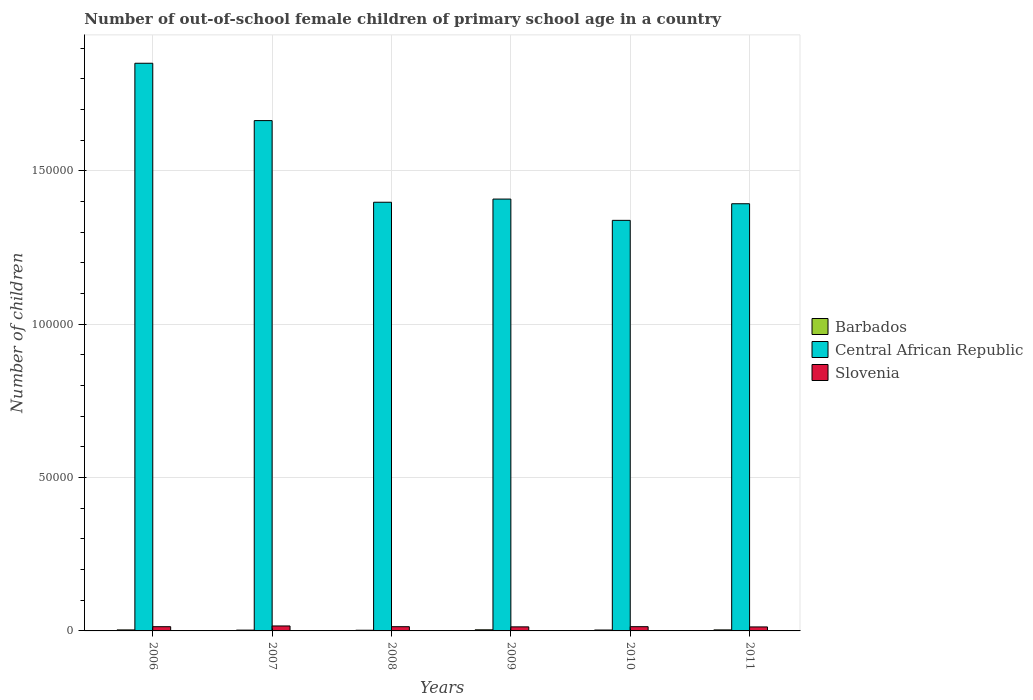How many groups of bars are there?
Give a very brief answer. 6. What is the label of the 5th group of bars from the left?
Your answer should be very brief. 2010. In how many cases, is the number of bars for a given year not equal to the number of legend labels?
Offer a terse response. 0. What is the number of out-of-school female children in Barbados in 2011?
Offer a terse response. 331. Across all years, what is the maximum number of out-of-school female children in Central African Republic?
Give a very brief answer. 1.85e+05. Across all years, what is the minimum number of out-of-school female children in Barbados?
Ensure brevity in your answer.  219. In which year was the number of out-of-school female children in Barbados minimum?
Your response must be concise. 2008. What is the total number of out-of-school female children in Central African Republic in the graph?
Offer a very short reply. 9.05e+05. What is the difference between the number of out-of-school female children in Central African Republic in 2008 and that in 2011?
Your answer should be very brief. 487. What is the difference between the number of out-of-school female children in Barbados in 2011 and the number of out-of-school female children in Central African Republic in 2009?
Your answer should be compact. -1.40e+05. What is the average number of out-of-school female children in Slovenia per year?
Your response must be concise. 1396.33. In the year 2007, what is the difference between the number of out-of-school female children in Slovenia and number of out-of-school female children in Central African Republic?
Give a very brief answer. -1.65e+05. In how many years, is the number of out-of-school female children in Slovenia greater than 160000?
Offer a very short reply. 0. What is the ratio of the number of out-of-school female children in Barbados in 2006 to that in 2011?
Ensure brevity in your answer.  0.99. Is the number of out-of-school female children in Central African Republic in 2006 less than that in 2009?
Your answer should be very brief. No. Is the difference between the number of out-of-school female children in Slovenia in 2010 and 2011 greater than the difference between the number of out-of-school female children in Central African Republic in 2010 and 2011?
Your answer should be very brief. Yes. What is the difference between the highest and the second highest number of out-of-school female children in Slovenia?
Offer a very short reply. 231. What is the difference between the highest and the lowest number of out-of-school female children in Slovenia?
Your answer should be very brief. 317. In how many years, is the number of out-of-school female children in Slovenia greater than the average number of out-of-school female children in Slovenia taken over all years?
Provide a succinct answer. 1. What does the 2nd bar from the left in 2010 represents?
Keep it short and to the point. Central African Republic. What does the 3rd bar from the right in 2009 represents?
Your response must be concise. Barbados. How many bars are there?
Ensure brevity in your answer.  18. Are all the bars in the graph horizontal?
Give a very brief answer. No. How many years are there in the graph?
Your answer should be compact. 6. What is the difference between two consecutive major ticks on the Y-axis?
Your answer should be very brief. 5.00e+04. Are the values on the major ticks of Y-axis written in scientific E-notation?
Offer a terse response. No. Does the graph contain grids?
Your response must be concise. Yes. How many legend labels are there?
Give a very brief answer. 3. What is the title of the graph?
Give a very brief answer. Number of out-of-school female children of primary school age in a country. Does "Israel" appear as one of the legend labels in the graph?
Provide a short and direct response. No. What is the label or title of the X-axis?
Your answer should be compact. Years. What is the label or title of the Y-axis?
Provide a short and direct response. Number of children. What is the Number of children in Barbados in 2006?
Keep it short and to the point. 327. What is the Number of children of Central African Republic in 2006?
Your answer should be compact. 1.85e+05. What is the Number of children in Slovenia in 2006?
Your response must be concise. 1377. What is the Number of children of Barbados in 2007?
Provide a short and direct response. 263. What is the Number of children in Central African Republic in 2007?
Your answer should be very brief. 1.66e+05. What is the Number of children in Slovenia in 2007?
Make the answer very short. 1616. What is the Number of children of Barbados in 2008?
Offer a very short reply. 219. What is the Number of children of Central African Republic in 2008?
Give a very brief answer. 1.40e+05. What is the Number of children of Slovenia in 2008?
Provide a short and direct response. 1377. What is the Number of children of Barbados in 2009?
Provide a succinct answer. 361. What is the Number of children in Central African Republic in 2009?
Your response must be concise. 1.41e+05. What is the Number of children of Slovenia in 2009?
Your answer should be compact. 1324. What is the Number of children in Barbados in 2010?
Give a very brief answer. 294. What is the Number of children in Central African Republic in 2010?
Offer a terse response. 1.34e+05. What is the Number of children in Slovenia in 2010?
Make the answer very short. 1385. What is the Number of children of Barbados in 2011?
Provide a succinct answer. 331. What is the Number of children in Central African Republic in 2011?
Give a very brief answer. 1.39e+05. What is the Number of children of Slovenia in 2011?
Keep it short and to the point. 1299. Across all years, what is the maximum Number of children of Barbados?
Make the answer very short. 361. Across all years, what is the maximum Number of children in Central African Republic?
Provide a succinct answer. 1.85e+05. Across all years, what is the maximum Number of children of Slovenia?
Your response must be concise. 1616. Across all years, what is the minimum Number of children of Barbados?
Offer a terse response. 219. Across all years, what is the minimum Number of children of Central African Republic?
Ensure brevity in your answer.  1.34e+05. Across all years, what is the minimum Number of children of Slovenia?
Offer a terse response. 1299. What is the total Number of children of Barbados in the graph?
Your response must be concise. 1795. What is the total Number of children of Central African Republic in the graph?
Offer a very short reply. 9.05e+05. What is the total Number of children in Slovenia in the graph?
Your answer should be compact. 8378. What is the difference between the Number of children of Central African Republic in 2006 and that in 2007?
Your answer should be very brief. 1.87e+04. What is the difference between the Number of children of Slovenia in 2006 and that in 2007?
Give a very brief answer. -239. What is the difference between the Number of children of Barbados in 2006 and that in 2008?
Provide a succinct answer. 108. What is the difference between the Number of children of Central African Republic in 2006 and that in 2008?
Ensure brevity in your answer.  4.53e+04. What is the difference between the Number of children in Slovenia in 2006 and that in 2008?
Ensure brevity in your answer.  0. What is the difference between the Number of children in Barbados in 2006 and that in 2009?
Give a very brief answer. -34. What is the difference between the Number of children in Central African Republic in 2006 and that in 2009?
Provide a short and direct response. 4.43e+04. What is the difference between the Number of children in Barbados in 2006 and that in 2010?
Offer a very short reply. 33. What is the difference between the Number of children in Central African Republic in 2006 and that in 2010?
Provide a short and direct response. 5.12e+04. What is the difference between the Number of children of Slovenia in 2006 and that in 2010?
Offer a terse response. -8. What is the difference between the Number of children of Barbados in 2006 and that in 2011?
Your response must be concise. -4. What is the difference between the Number of children in Central African Republic in 2006 and that in 2011?
Give a very brief answer. 4.58e+04. What is the difference between the Number of children of Slovenia in 2006 and that in 2011?
Give a very brief answer. 78. What is the difference between the Number of children of Barbados in 2007 and that in 2008?
Your answer should be very brief. 44. What is the difference between the Number of children of Central African Republic in 2007 and that in 2008?
Provide a short and direct response. 2.66e+04. What is the difference between the Number of children of Slovenia in 2007 and that in 2008?
Your response must be concise. 239. What is the difference between the Number of children in Barbados in 2007 and that in 2009?
Your answer should be compact. -98. What is the difference between the Number of children in Central African Republic in 2007 and that in 2009?
Provide a succinct answer. 2.56e+04. What is the difference between the Number of children in Slovenia in 2007 and that in 2009?
Make the answer very short. 292. What is the difference between the Number of children in Barbados in 2007 and that in 2010?
Keep it short and to the point. -31. What is the difference between the Number of children in Central African Republic in 2007 and that in 2010?
Provide a short and direct response. 3.25e+04. What is the difference between the Number of children in Slovenia in 2007 and that in 2010?
Your answer should be very brief. 231. What is the difference between the Number of children in Barbados in 2007 and that in 2011?
Your answer should be very brief. -68. What is the difference between the Number of children of Central African Republic in 2007 and that in 2011?
Provide a succinct answer. 2.71e+04. What is the difference between the Number of children in Slovenia in 2007 and that in 2011?
Provide a short and direct response. 317. What is the difference between the Number of children in Barbados in 2008 and that in 2009?
Provide a short and direct response. -142. What is the difference between the Number of children in Central African Republic in 2008 and that in 2009?
Give a very brief answer. -1034. What is the difference between the Number of children of Slovenia in 2008 and that in 2009?
Make the answer very short. 53. What is the difference between the Number of children of Barbados in 2008 and that in 2010?
Keep it short and to the point. -75. What is the difference between the Number of children of Central African Republic in 2008 and that in 2010?
Offer a terse response. 5907. What is the difference between the Number of children of Slovenia in 2008 and that in 2010?
Ensure brevity in your answer.  -8. What is the difference between the Number of children of Barbados in 2008 and that in 2011?
Offer a terse response. -112. What is the difference between the Number of children in Central African Republic in 2008 and that in 2011?
Give a very brief answer. 487. What is the difference between the Number of children of Central African Republic in 2009 and that in 2010?
Provide a succinct answer. 6941. What is the difference between the Number of children in Slovenia in 2009 and that in 2010?
Your answer should be very brief. -61. What is the difference between the Number of children in Barbados in 2009 and that in 2011?
Ensure brevity in your answer.  30. What is the difference between the Number of children of Central African Republic in 2009 and that in 2011?
Your response must be concise. 1521. What is the difference between the Number of children in Slovenia in 2009 and that in 2011?
Make the answer very short. 25. What is the difference between the Number of children of Barbados in 2010 and that in 2011?
Your answer should be very brief. -37. What is the difference between the Number of children of Central African Republic in 2010 and that in 2011?
Provide a short and direct response. -5420. What is the difference between the Number of children in Barbados in 2006 and the Number of children in Central African Republic in 2007?
Keep it short and to the point. -1.66e+05. What is the difference between the Number of children of Barbados in 2006 and the Number of children of Slovenia in 2007?
Your response must be concise. -1289. What is the difference between the Number of children in Central African Republic in 2006 and the Number of children in Slovenia in 2007?
Give a very brief answer. 1.83e+05. What is the difference between the Number of children in Barbados in 2006 and the Number of children in Central African Republic in 2008?
Your response must be concise. -1.39e+05. What is the difference between the Number of children in Barbados in 2006 and the Number of children in Slovenia in 2008?
Make the answer very short. -1050. What is the difference between the Number of children of Central African Republic in 2006 and the Number of children of Slovenia in 2008?
Give a very brief answer. 1.84e+05. What is the difference between the Number of children in Barbados in 2006 and the Number of children in Central African Republic in 2009?
Give a very brief answer. -1.40e+05. What is the difference between the Number of children in Barbados in 2006 and the Number of children in Slovenia in 2009?
Keep it short and to the point. -997. What is the difference between the Number of children in Central African Republic in 2006 and the Number of children in Slovenia in 2009?
Provide a succinct answer. 1.84e+05. What is the difference between the Number of children in Barbados in 2006 and the Number of children in Central African Republic in 2010?
Keep it short and to the point. -1.34e+05. What is the difference between the Number of children of Barbados in 2006 and the Number of children of Slovenia in 2010?
Provide a short and direct response. -1058. What is the difference between the Number of children in Central African Republic in 2006 and the Number of children in Slovenia in 2010?
Your answer should be very brief. 1.84e+05. What is the difference between the Number of children of Barbados in 2006 and the Number of children of Central African Republic in 2011?
Provide a short and direct response. -1.39e+05. What is the difference between the Number of children in Barbados in 2006 and the Number of children in Slovenia in 2011?
Your response must be concise. -972. What is the difference between the Number of children of Central African Republic in 2006 and the Number of children of Slovenia in 2011?
Give a very brief answer. 1.84e+05. What is the difference between the Number of children of Barbados in 2007 and the Number of children of Central African Republic in 2008?
Keep it short and to the point. -1.40e+05. What is the difference between the Number of children in Barbados in 2007 and the Number of children in Slovenia in 2008?
Provide a short and direct response. -1114. What is the difference between the Number of children in Central African Republic in 2007 and the Number of children in Slovenia in 2008?
Provide a succinct answer. 1.65e+05. What is the difference between the Number of children in Barbados in 2007 and the Number of children in Central African Republic in 2009?
Make the answer very short. -1.41e+05. What is the difference between the Number of children of Barbados in 2007 and the Number of children of Slovenia in 2009?
Your response must be concise. -1061. What is the difference between the Number of children in Central African Republic in 2007 and the Number of children in Slovenia in 2009?
Ensure brevity in your answer.  1.65e+05. What is the difference between the Number of children of Barbados in 2007 and the Number of children of Central African Republic in 2010?
Your answer should be very brief. -1.34e+05. What is the difference between the Number of children in Barbados in 2007 and the Number of children in Slovenia in 2010?
Offer a terse response. -1122. What is the difference between the Number of children in Central African Republic in 2007 and the Number of children in Slovenia in 2010?
Provide a short and direct response. 1.65e+05. What is the difference between the Number of children in Barbados in 2007 and the Number of children in Central African Republic in 2011?
Offer a very short reply. -1.39e+05. What is the difference between the Number of children of Barbados in 2007 and the Number of children of Slovenia in 2011?
Keep it short and to the point. -1036. What is the difference between the Number of children in Central African Republic in 2007 and the Number of children in Slovenia in 2011?
Provide a succinct answer. 1.65e+05. What is the difference between the Number of children in Barbados in 2008 and the Number of children in Central African Republic in 2009?
Keep it short and to the point. -1.41e+05. What is the difference between the Number of children in Barbados in 2008 and the Number of children in Slovenia in 2009?
Make the answer very short. -1105. What is the difference between the Number of children of Central African Republic in 2008 and the Number of children of Slovenia in 2009?
Your response must be concise. 1.38e+05. What is the difference between the Number of children of Barbados in 2008 and the Number of children of Central African Republic in 2010?
Make the answer very short. -1.34e+05. What is the difference between the Number of children of Barbados in 2008 and the Number of children of Slovenia in 2010?
Your response must be concise. -1166. What is the difference between the Number of children in Central African Republic in 2008 and the Number of children in Slovenia in 2010?
Provide a succinct answer. 1.38e+05. What is the difference between the Number of children of Barbados in 2008 and the Number of children of Central African Republic in 2011?
Provide a short and direct response. -1.39e+05. What is the difference between the Number of children of Barbados in 2008 and the Number of children of Slovenia in 2011?
Your response must be concise. -1080. What is the difference between the Number of children of Central African Republic in 2008 and the Number of children of Slovenia in 2011?
Your answer should be very brief. 1.38e+05. What is the difference between the Number of children of Barbados in 2009 and the Number of children of Central African Republic in 2010?
Offer a terse response. -1.34e+05. What is the difference between the Number of children in Barbados in 2009 and the Number of children in Slovenia in 2010?
Make the answer very short. -1024. What is the difference between the Number of children of Central African Republic in 2009 and the Number of children of Slovenia in 2010?
Your answer should be compact. 1.39e+05. What is the difference between the Number of children in Barbados in 2009 and the Number of children in Central African Republic in 2011?
Offer a very short reply. -1.39e+05. What is the difference between the Number of children in Barbados in 2009 and the Number of children in Slovenia in 2011?
Provide a short and direct response. -938. What is the difference between the Number of children of Central African Republic in 2009 and the Number of children of Slovenia in 2011?
Provide a succinct answer. 1.40e+05. What is the difference between the Number of children in Barbados in 2010 and the Number of children in Central African Republic in 2011?
Your answer should be very brief. -1.39e+05. What is the difference between the Number of children of Barbados in 2010 and the Number of children of Slovenia in 2011?
Make the answer very short. -1005. What is the difference between the Number of children of Central African Republic in 2010 and the Number of children of Slovenia in 2011?
Give a very brief answer. 1.33e+05. What is the average Number of children of Barbados per year?
Make the answer very short. 299.17. What is the average Number of children in Central African Republic per year?
Make the answer very short. 1.51e+05. What is the average Number of children of Slovenia per year?
Your response must be concise. 1396.33. In the year 2006, what is the difference between the Number of children in Barbados and Number of children in Central African Republic?
Offer a terse response. -1.85e+05. In the year 2006, what is the difference between the Number of children in Barbados and Number of children in Slovenia?
Your answer should be compact. -1050. In the year 2006, what is the difference between the Number of children of Central African Republic and Number of children of Slovenia?
Keep it short and to the point. 1.84e+05. In the year 2007, what is the difference between the Number of children of Barbados and Number of children of Central African Republic?
Give a very brief answer. -1.66e+05. In the year 2007, what is the difference between the Number of children in Barbados and Number of children in Slovenia?
Offer a terse response. -1353. In the year 2007, what is the difference between the Number of children of Central African Republic and Number of children of Slovenia?
Give a very brief answer. 1.65e+05. In the year 2008, what is the difference between the Number of children of Barbados and Number of children of Central African Republic?
Make the answer very short. -1.40e+05. In the year 2008, what is the difference between the Number of children in Barbados and Number of children in Slovenia?
Provide a succinct answer. -1158. In the year 2008, what is the difference between the Number of children in Central African Republic and Number of children in Slovenia?
Your answer should be very brief. 1.38e+05. In the year 2009, what is the difference between the Number of children in Barbados and Number of children in Central African Republic?
Your response must be concise. -1.40e+05. In the year 2009, what is the difference between the Number of children in Barbados and Number of children in Slovenia?
Make the answer very short. -963. In the year 2009, what is the difference between the Number of children of Central African Republic and Number of children of Slovenia?
Provide a succinct answer. 1.39e+05. In the year 2010, what is the difference between the Number of children of Barbados and Number of children of Central African Republic?
Your response must be concise. -1.34e+05. In the year 2010, what is the difference between the Number of children in Barbados and Number of children in Slovenia?
Provide a short and direct response. -1091. In the year 2010, what is the difference between the Number of children of Central African Republic and Number of children of Slovenia?
Keep it short and to the point. 1.32e+05. In the year 2011, what is the difference between the Number of children in Barbados and Number of children in Central African Republic?
Make the answer very short. -1.39e+05. In the year 2011, what is the difference between the Number of children of Barbados and Number of children of Slovenia?
Give a very brief answer. -968. In the year 2011, what is the difference between the Number of children of Central African Republic and Number of children of Slovenia?
Your answer should be compact. 1.38e+05. What is the ratio of the Number of children of Barbados in 2006 to that in 2007?
Your answer should be compact. 1.24. What is the ratio of the Number of children in Central African Republic in 2006 to that in 2007?
Your answer should be compact. 1.11. What is the ratio of the Number of children in Slovenia in 2006 to that in 2007?
Offer a very short reply. 0.85. What is the ratio of the Number of children of Barbados in 2006 to that in 2008?
Your response must be concise. 1.49. What is the ratio of the Number of children of Central African Republic in 2006 to that in 2008?
Your answer should be very brief. 1.32. What is the ratio of the Number of children of Slovenia in 2006 to that in 2008?
Make the answer very short. 1. What is the ratio of the Number of children of Barbados in 2006 to that in 2009?
Give a very brief answer. 0.91. What is the ratio of the Number of children of Central African Republic in 2006 to that in 2009?
Give a very brief answer. 1.31. What is the ratio of the Number of children in Barbados in 2006 to that in 2010?
Provide a succinct answer. 1.11. What is the ratio of the Number of children in Central African Republic in 2006 to that in 2010?
Offer a very short reply. 1.38. What is the ratio of the Number of children in Barbados in 2006 to that in 2011?
Offer a terse response. 0.99. What is the ratio of the Number of children in Central African Republic in 2006 to that in 2011?
Your response must be concise. 1.33. What is the ratio of the Number of children of Slovenia in 2006 to that in 2011?
Keep it short and to the point. 1.06. What is the ratio of the Number of children of Barbados in 2007 to that in 2008?
Give a very brief answer. 1.2. What is the ratio of the Number of children in Central African Republic in 2007 to that in 2008?
Your answer should be compact. 1.19. What is the ratio of the Number of children in Slovenia in 2007 to that in 2008?
Offer a terse response. 1.17. What is the ratio of the Number of children of Barbados in 2007 to that in 2009?
Your response must be concise. 0.73. What is the ratio of the Number of children of Central African Republic in 2007 to that in 2009?
Keep it short and to the point. 1.18. What is the ratio of the Number of children in Slovenia in 2007 to that in 2009?
Your answer should be compact. 1.22. What is the ratio of the Number of children of Barbados in 2007 to that in 2010?
Make the answer very short. 0.89. What is the ratio of the Number of children in Central African Republic in 2007 to that in 2010?
Your response must be concise. 1.24. What is the ratio of the Number of children in Slovenia in 2007 to that in 2010?
Give a very brief answer. 1.17. What is the ratio of the Number of children in Barbados in 2007 to that in 2011?
Keep it short and to the point. 0.79. What is the ratio of the Number of children of Central African Republic in 2007 to that in 2011?
Offer a very short reply. 1.19. What is the ratio of the Number of children in Slovenia in 2007 to that in 2011?
Keep it short and to the point. 1.24. What is the ratio of the Number of children in Barbados in 2008 to that in 2009?
Your answer should be very brief. 0.61. What is the ratio of the Number of children of Slovenia in 2008 to that in 2009?
Offer a terse response. 1.04. What is the ratio of the Number of children in Barbados in 2008 to that in 2010?
Offer a terse response. 0.74. What is the ratio of the Number of children in Central African Republic in 2008 to that in 2010?
Provide a succinct answer. 1.04. What is the ratio of the Number of children in Slovenia in 2008 to that in 2010?
Keep it short and to the point. 0.99. What is the ratio of the Number of children in Barbados in 2008 to that in 2011?
Offer a terse response. 0.66. What is the ratio of the Number of children of Slovenia in 2008 to that in 2011?
Offer a terse response. 1.06. What is the ratio of the Number of children of Barbados in 2009 to that in 2010?
Your answer should be compact. 1.23. What is the ratio of the Number of children of Central African Republic in 2009 to that in 2010?
Give a very brief answer. 1.05. What is the ratio of the Number of children in Slovenia in 2009 to that in 2010?
Offer a terse response. 0.96. What is the ratio of the Number of children of Barbados in 2009 to that in 2011?
Your response must be concise. 1.09. What is the ratio of the Number of children of Central African Republic in 2009 to that in 2011?
Make the answer very short. 1.01. What is the ratio of the Number of children of Slovenia in 2009 to that in 2011?
Keep it short and to the point. 1.02. What is the ratio of the Number of children in Barbados in 2010 to that in 2011?
Provide a short and direct response. 0.89. What is the ratio of the Number of children in Central African Republic in 2010 to that in 2011?
Ensure brevity in your answer.  0.96. What is the ratio of the Number of children of Slovenia in 2010 to that in 2011?
Offer a terse response. 1.07. What is the difference between the highest and the second highest Number of children in Central African Republic?
Offer a very short reply. 1.87e+04. What is the difference between the highest and the second highest Number of children of Slovenia?
Your answer should be very brief. 231. What is the difference between the highest and the lowest Number of children in Barbados?
Make the answer very short. 142. What is the difference between the highest and the lowest Number of children in Central African Republic?
Your answer should be very brief. 5.12e+04. What is the difference between the highest and the lowest Number of children in Slovenia?
Provide a short and direct response. 317. 